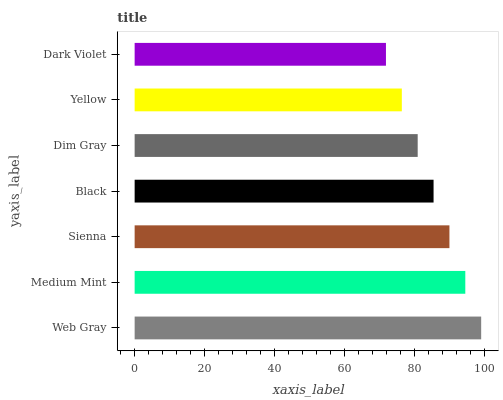Is Dark Violet the minimum?
Answer yes or no. Yes. Is Web Gray the maximum?
Answer yes or no. Yes. Is Medium Mint the minimum?
Answer yes or no. No. Is Medium Mint the maximum?
Answer yes or no. No. Is Web Gray greater than Medium Mint?
Answer yes or no. Yes. Is Medium Mint less than Web Gray?
Answer yes or no. Yes. Is Medium Mint greater than Web Gray?
Answer yes or no. No. Is Web Gray less than Medium Mint?
Answer yes or no. No. Is Black the high median?
Answer yes or no. Yes. Is Black the low median?
Answer yes or no. Yes. Is Yellow the high median?
Answer yes or no. No. Is Dark Violet the low median?
Answer yes or no. No. 